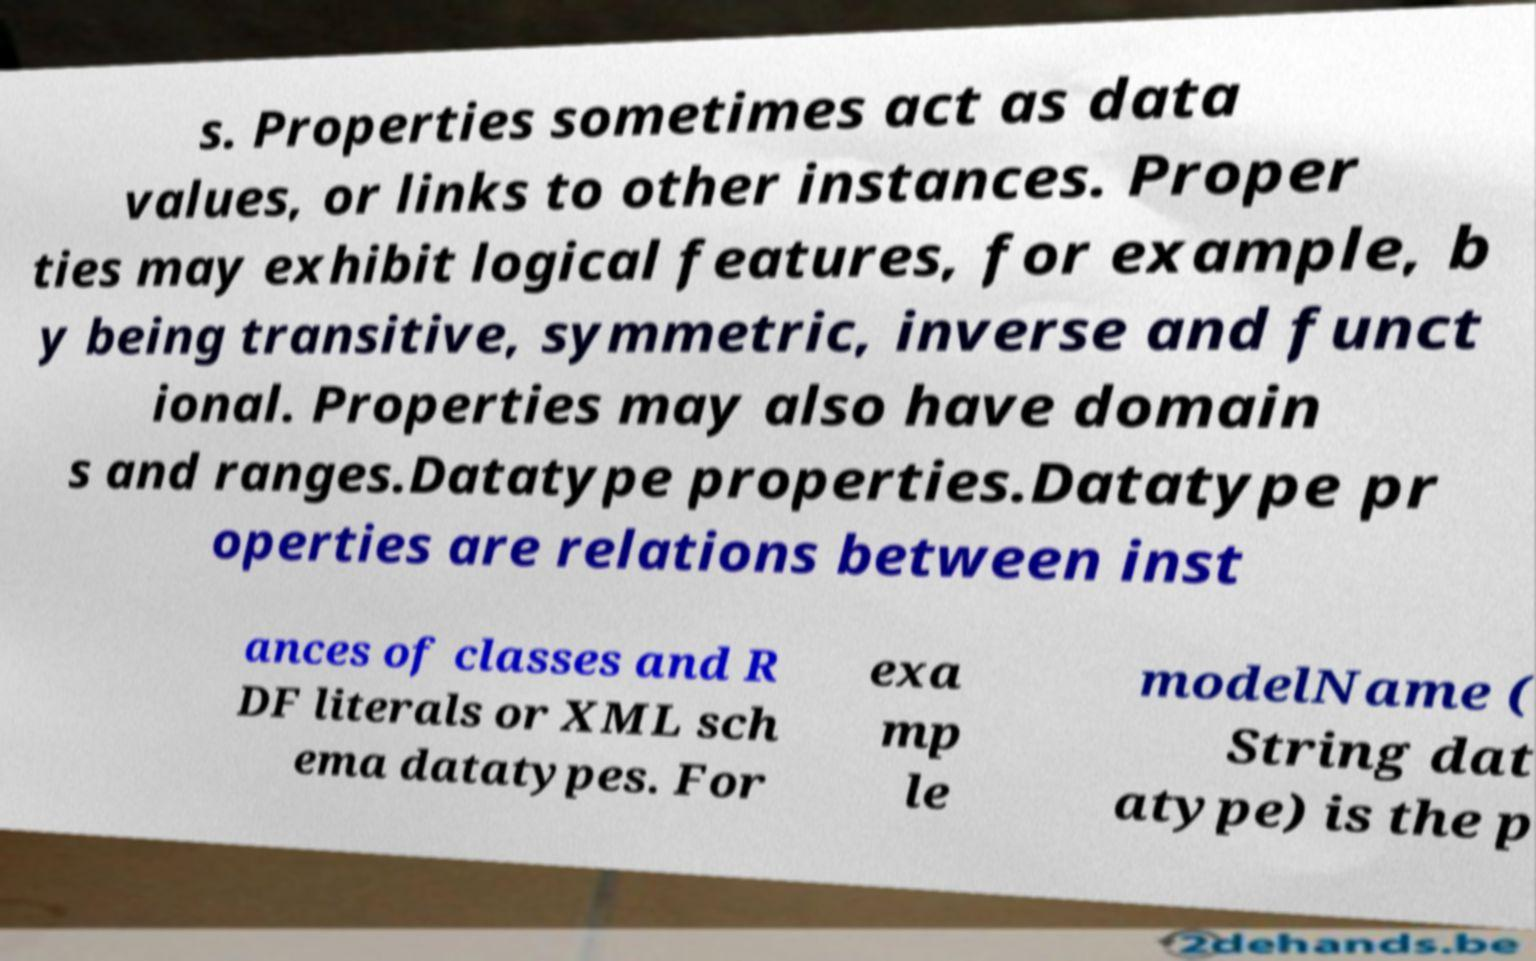Can you accurately transcribe the text from the provided image for me? s. Properties sometimes act as data values, or links to other instances. Proper ties may exhibit logical features, for example, b y being transitive, symmetric, inverse and funct ional. Properties may also have domain s and ranges.Datatype properties.Datatype pr operties are relations between inst ances of classes and R DF literals or XML sch ema datatypes. For exa mp le modelName ( String dat atype) is the p 